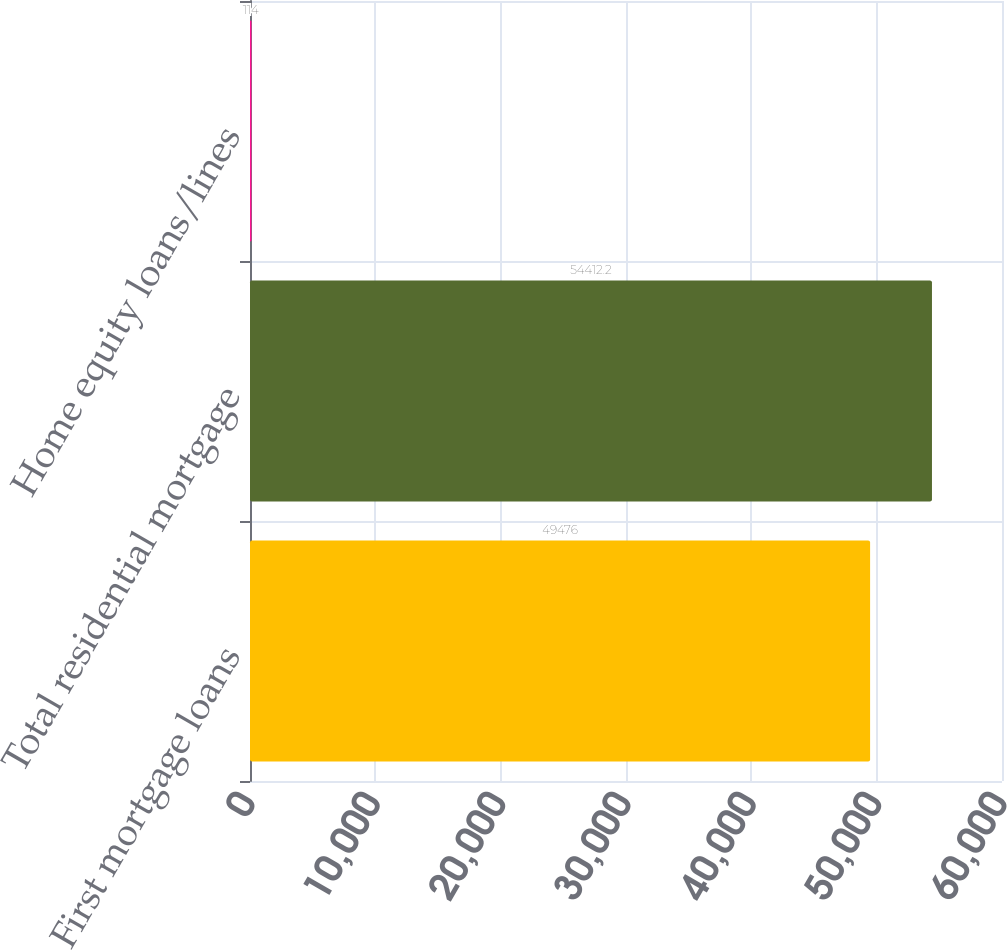Convert chart to OTSL. <chart><loc_0><loc_0><loc_500><loc_500><bar_chart><fcel>First mortgage loans<fcel>Total residential mortgage<fcel>Home equity loans/lines<nl><fcel>49476<fcel>54412.2<fcel>114<nl></chart> 